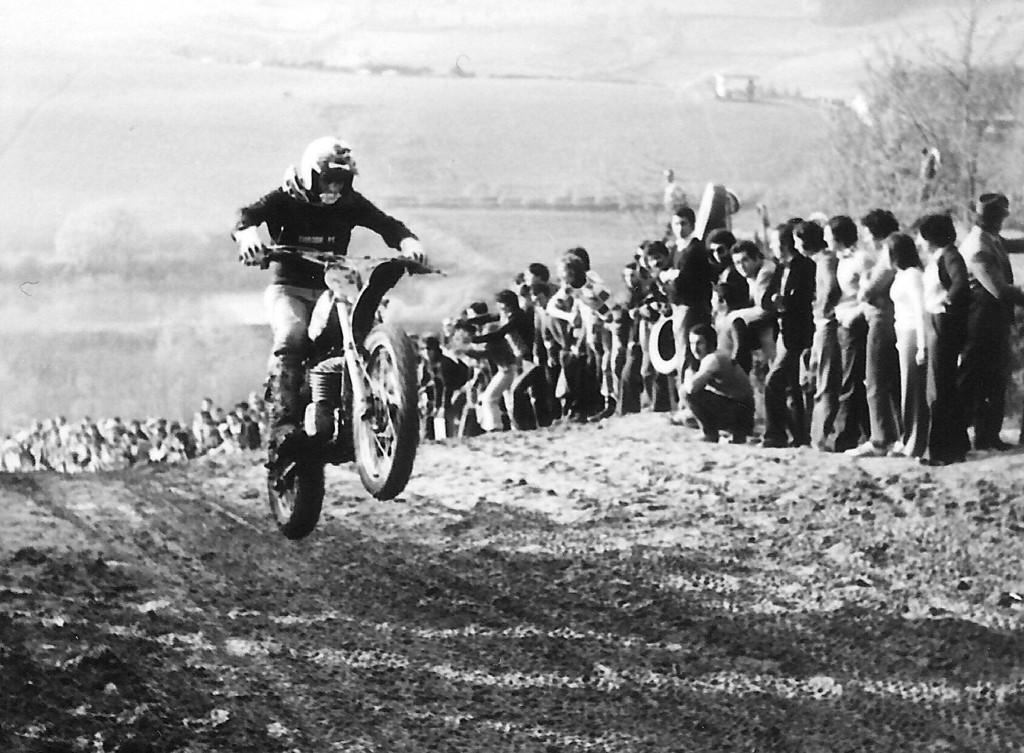Describe this image in one or two sentences. In this image there are group of people and a motorcyclist racing and doing wheelie and at the background there are trees. 